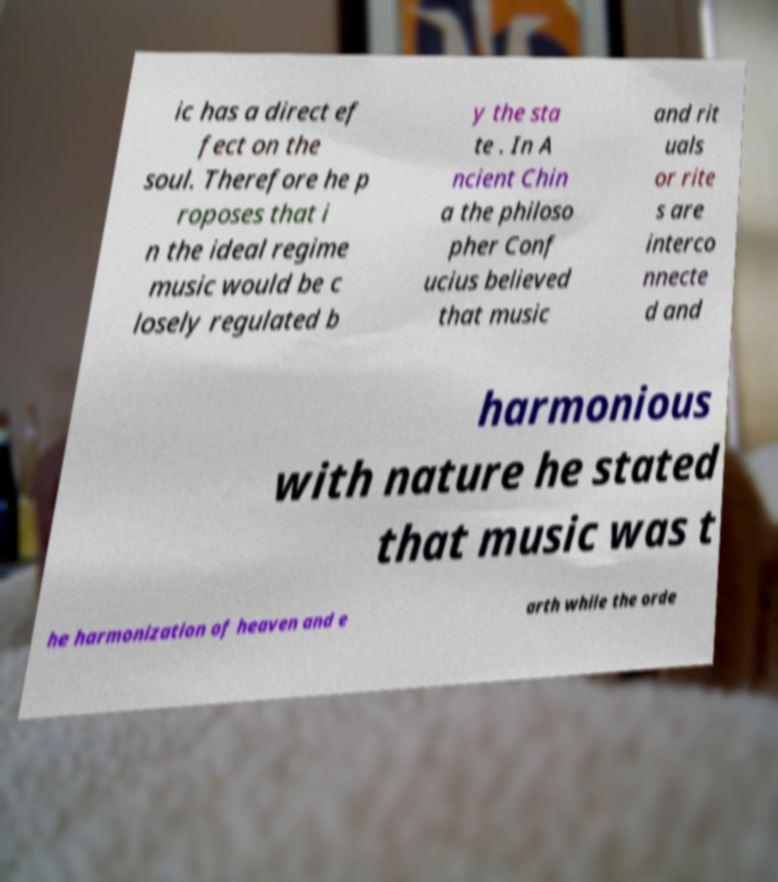Can you read and provide the text displayed in the image?This photo seems to have some interesting text. Can you extract and type it out for me? ic has a direct ef fect on the soul. Therefore he p roposes that i n the ideal regime music would be c losely regulated b y the sta te . In A ncient Chin a the philoso pher Conf ucius believed that music and rit uals or rite s are interco nnecte d and harmonious with nature he stated that music was t he harmonization of heaven and e arth while the orde 